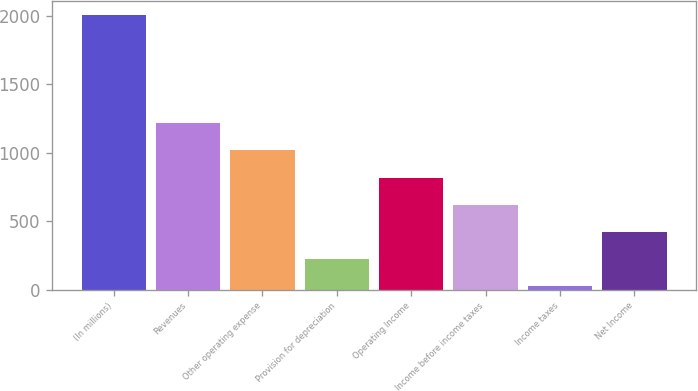Convert chart to OTSL. <chart><loc_0><loc_0><loc_500><loc_500><bar_chart><fcel>(In millions)<fcel>Revenues<fcel>Other operating expense<fcel>Provision for depreciation<fcel>Operating Income<fcel>Income before income taxes<fcel>Income taxes<fcel>Net Income<nl><fcel>2010<fcel>1215.6<fcel>1017<fcel>222.6<fcel>818.4<fcel>619.8<fcel>24<fcel>421.2<nl></chart> 